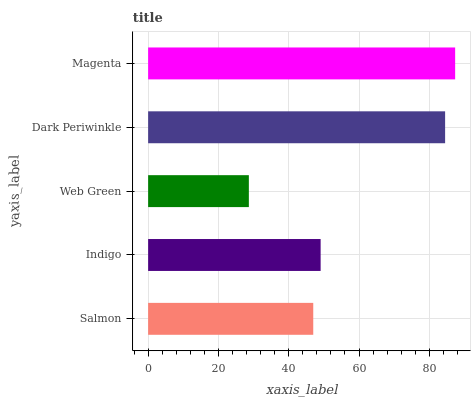Is Web Green the minimum?
Answer yes or no. Yes. Is Magenta the maximum?
Answer yes or no. Yes. Is Indigo the minimum?
Answer yes or no. No. Is Indigo the maximum?
Answer yes or no. No. Is Indigo greater than Salmon?
Answer yes or no. Yes. Is Salmon less than Indigo?
Answer yes or no. Yes. Is Salmon greater than Indigo?
Answer yes or no. No. Is Indigo less than Salmon?
Answer yes or no. No. Is Indigo the high median?
Answer yes or no. Yes. Is Indigo the low median?
Answer yes or no. Yes. Is Dark Periwinkle the high median?
Answer yes or no. No. Is Dark Periwinkle the low median?
Answer yes or no. No. 